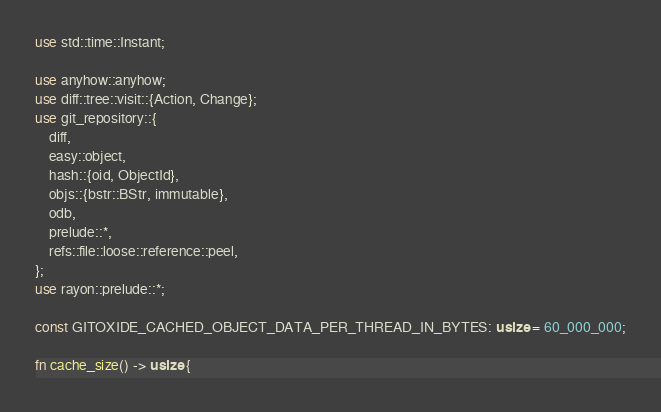Convert code to text. <code><loc_0><loc_0><loc_500><loc_500><_Rust_>use std::time::Instant;

use anyhow::anyhow;
use diff::tree::visit::{Action, Change};
use git_repository::{
    diff,
    easy::object,
    hash::{oid, ObjectId},
    objs::{bstr::BStr, immutable},
    odb,
    prelude::*,
    refs::file::loose::reference::peel,
};
use rayon::prelude::*;

const GITOXIDE_CACHED_OBJECT_DATA_PER_THREAD_IN_BYTES: usize = 60_000_000;

fn cache_size() -> usize {</code> 